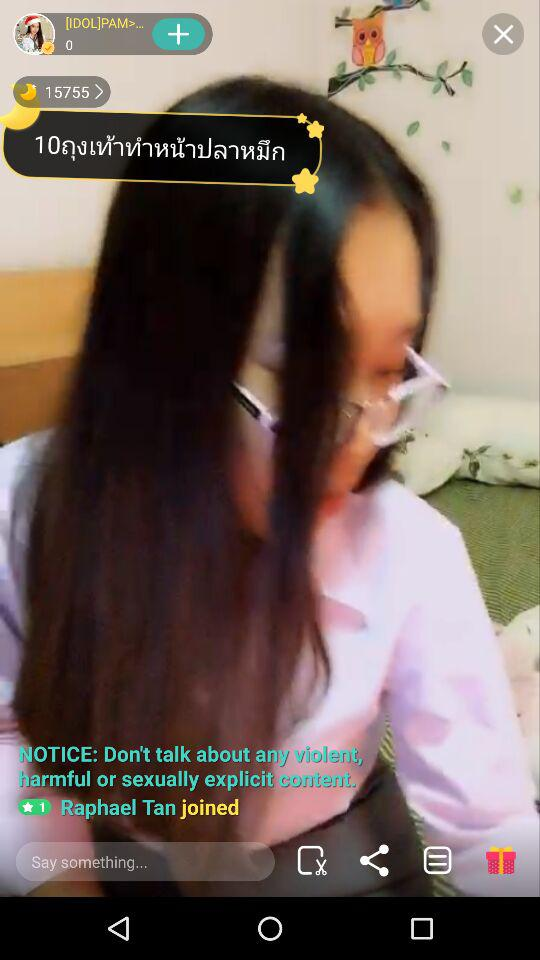How many stars are given? There is 1 star given. 